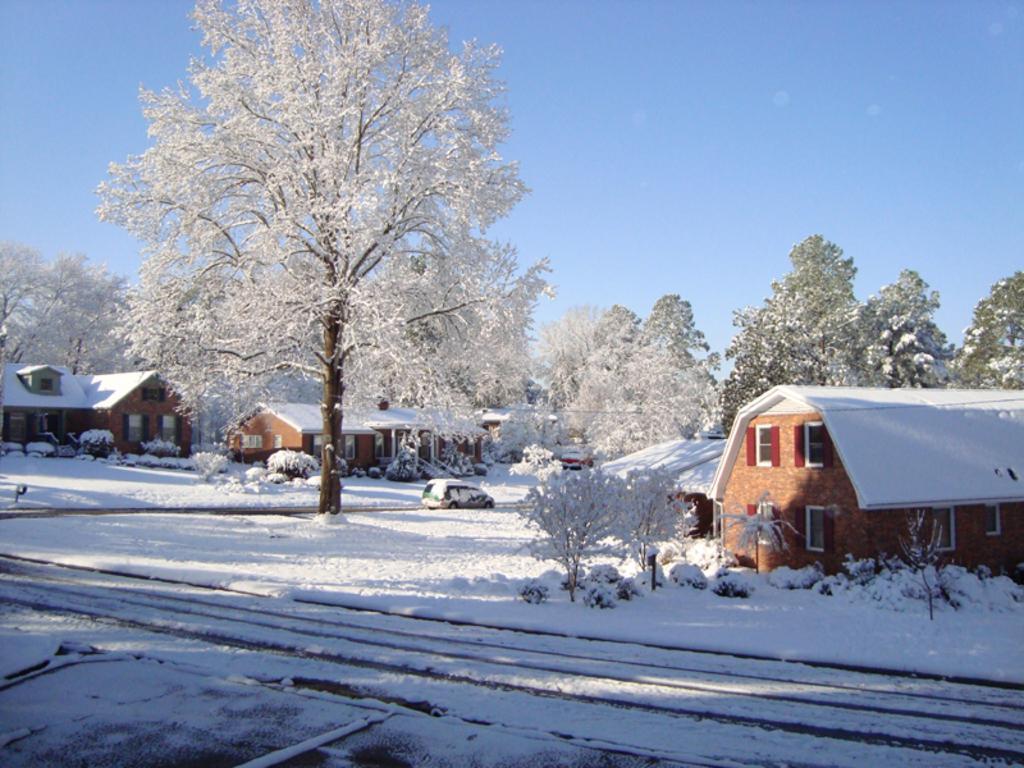In one or two sentences, can you explain what this image depicts? We can see snow, planets, houses and car on the road. In the background we can see trees and sky. 